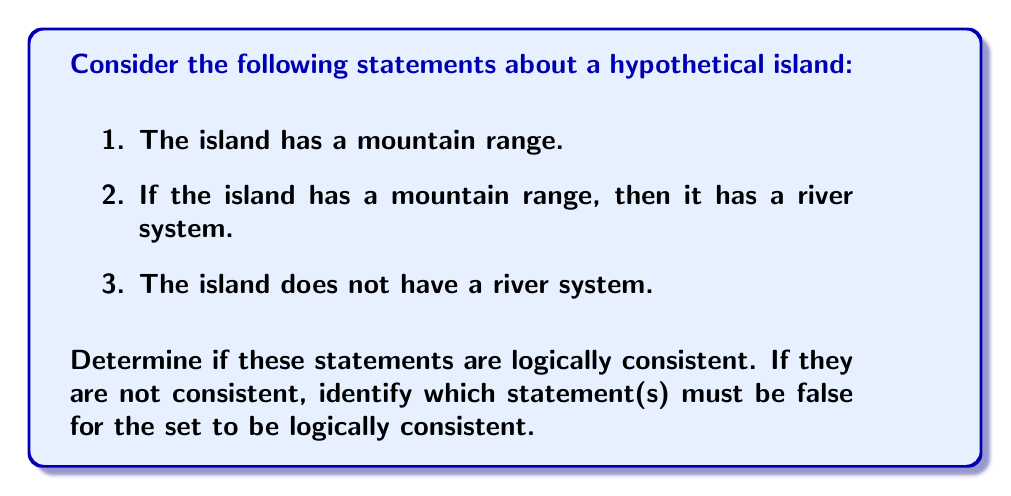Provide a solution to this math problem. Let's approach this step-by-step using propositional logic:

1. Let M represent "The island has a mountain range"
2. Let R represent "The island has a river system"

We can translate the statements into logical propositions:

1. M
2. M → R (If M, then R)
3. ¬R (not R)

To check for consistency, we'll use a proof by contradiction:

Step 1: Assume all statements are true.

Step 2: From statement 1, we know M is true.

Step 3: From statement 2, we know M → R. Since M is true (from step 2), we can apply modus ponens:
$$(M \land (M \rightarrow R)) \rightarrow R$$
Therefore, R must be true.

Step 4: However, statement 3 says ¬R (R is false).

Step 5: We have derived both R and ¬R, which is a contradiction.

Therefore, these statements are not logically consistent.

To make them consistent, we must negate one of the statements. We have three options:

a) Negate statement 1: The island does not have a mountain range (¬M)
b) Negate statement 2: The island can have a mountain range without a river system (¬(M → R))
c) Negate statement 3: The island does have a river system (R)

Any one of these negations would make the set of statements logically consistent.
Answer: Not consistent; negate any one statement to achieve consistency. 